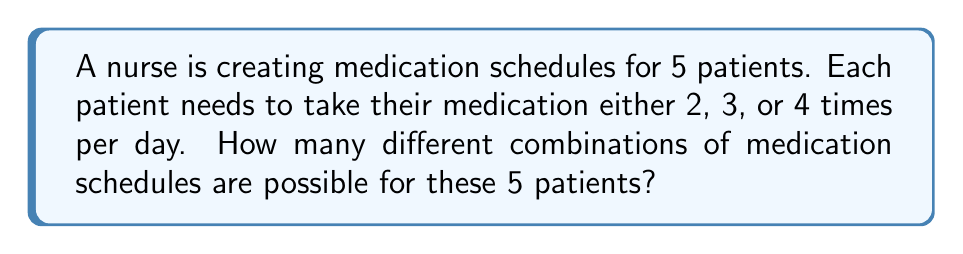Could you help me with this problem? Let's approach this step-by-step:

1) We have 5 patients, and each patient has 3 options for their medication schedule (2, 3, or 4 times per day).

2) This is a case of independent choices. For each patient, we make a choice that doesn't affect the choices for other patients.

3) When we have independent choices, we use the multiplication principle of counting.

4) The multiplication principle states that if we have $m$ ways of doing something and $n$ ways of doing another thing, there are $m \times n$ ways of doing both things.

5) In this case, we're making 5 independent choices (one for each patient), and each choice has 3 options.

6) Therefore, the total number of possible combinations is:

   $$ 3 \times 3 \times 3 \times 3 \times 3 = 3^5 $$

7) Let's calculate this:
   $$ 3^5 = 3 \times 3 \times 3 \times 3 \times 3 = 243 $$

Thus, there are 243 different possible combinations of medication schedules for these 5 patients.
Answer: 243 